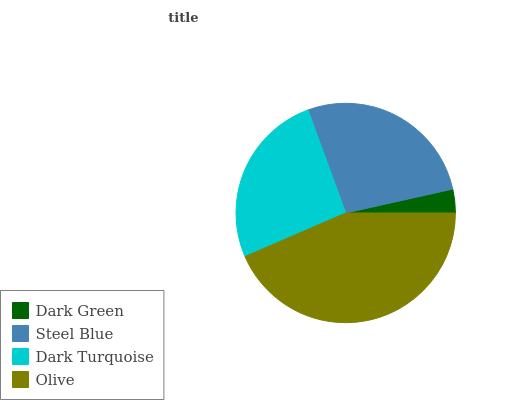Is Dark Green the minimum?
Answer yes or no. Yes. Is Olive the maximum?
Answer yes or no. Yes. Is Steel Blue the minimum?
Answer yes or no. No. Is Steel Blue the maximum?
Answer yes or no. No. Is Steel Blue greater than Dark Green?
Answer yes or no. Yes. Is Dark Green less than Steel Blue?
Answer yes or no. Yes. Is Dark Green greater than Steel Blue?
Answer yes or no. No. Is Steel Blue less than Dark Green?
Answer yes or no. No. Is Steel Blue the high median?
Answer yes or no. Yes. Is Dark Turquoise the low median?
Answer yes or no. Yes. Is Dark Turquoise the high median?
Answer yes or no. No. Is Steel Blue the low median?
Answer yes or no. No. 